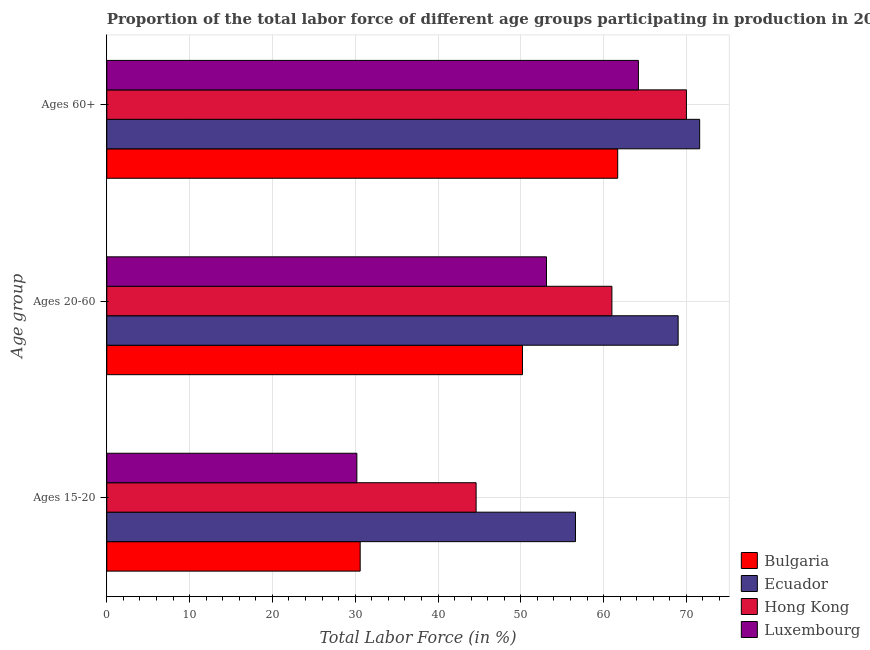How many different coloured bars are there?
Ensure brevity in your answer.  4. Are the number of bars per tick equal to the number of legend labels?
Give a very brief answer. Yes. Are the number of bars on each tick of the Y-axis equal?
Keep it short and to the point. Yes. How many bars are there on the 2nd tick from the top?
Make the answer very short. 4. What is the label of the 2nd group of bars from the top?
Give a very brief answer. Ages 20-60. What is the percentage of labor force within the age group 15-20 in Bulgaria?
Provide a short and direct response. 30.6. Across all countries, what is the maximum percentage of labor force within the age group 20-60?
Offer a terse response. 69. Across all countries, what is the minimum percentage of labor force within the age group 15-20?
Ensure brevity in your answer.  30.2. In which country was the percentage of labor force within the age group 20-60 maximum?
Give a very brief answer. Ecuador. In which country was the percentage of labor force within the age group 20-60 minimum?
Offer a very short reply. Bulgaria. What is the total percentage of labor force within the age group 20-60 in the graph?
Give a very brief answer. 233.3. What is the difference between the percentage of labor force above age 60 in Bulgaria and that in Luxembourg?
Make the answer very short. -2.5. What is the difference between the percentage of labor force within the age group 15-20 in Bulgaria and the percentage of labor force within the age group 20-60 in Luxembourg?
Keep it short and to the point. -22.5. What is the average percentage of labor force above age 60 per country?
Offer a very short reply. 66.87. What is the difference between the percentage of labor force within the age group 20-60 and percentage of labor force within the age group 15-20 in Hong Kong?
Your answer should be compact. 16.4. What is the ratio of the percentage of labor force within the age group 20-60 in Hong Kong to that in Bulgaria?
Give a very brief answer. 1.22. Is the percentage of labor force within the age group 15-20 in Hong Kong less than that in Bulgaria?
Your response must be concise. No. Is the difference between the percentage of labor force above age 60 in Ecuador and Luxembourg greater than the difference between the percentage of labor force within the age group 15-20 in Ecuador and Luxembourg?
Ensure brevity in your answer.  No. What is the difference between the highest and the lowest percentage of labor force within the age group 20-60?
Ensure brevity in your answer.  18.8. In how many countries, is the percentage of labor force above age 60 greater than the average percentage of labor force above age 60 taken over all countries?
Your answer should be compact. 2. Is the sum of the percentage of labor force within the age group 15-20 in Ecuador and Bulgaria greater than the maximum percentage of labor force above age 60 across all countries?
Provide a succinct answer. Yes. What does the 3rd bar from the top in Ages 20-60 represents?
Your answer should be very brief. Ecuador. What does the 4th bar from the bottom in Ages 15-20 represents?
Your response must be concise. Luxembourg. Is it the case that in every country, the sum of the percentage of labor force within the age group 15-20 and percentage of labor force within the age group 20-60 is greater than the percentage of labor force above age 60?
Make the answer very short. Yes. Are all the bars in the graph horizontal?
Provide a short and direct response. Yes. Does the graph contain any zero values?
Your response must be concise. No. Does the graph contain grids?
Keep it short and to the point. Yes. How are the legend labels stacked?
Offer a very short reply. Vertical. What is the title of the graph?
Your response must be concise. Proportion of the total labor force of different age groups participating in production in 2003. Does "Middle East & North Africa (all income levels)" appear as one of the legend labels in the graph?
Your answer should be compact. No. What is the label or title of the Y-axis?
Provide a succinct answer. Age group. What is the Total Labor Force (in %) in Bulgaria in Ages 15-20?
Give a very brief answer. 30.6. What is the Total Labor Force (in %) in Ecuador in Ages 15-20?
Keep it short and to the point. 56.6. What is the Total Labor Force (in %) of Hong Kong in Ages 15-20?
Your response must be concise. 44.6. What is the Total Labor Force (in %) of Luxembourg in Ages 15-20?
Your answer should be compact. 30.2. What is the Total Labor Force (in %) in Bulgaria in Ages 20-60?
Provide a succinct answer. 50.2. What is the Total Labor Force (in %) of Luxembourg in Ages 20-60?
Your answer should be compact. 53.1. What is the Total Labor Force (in %) of Bulgaria in Ages 60+?
Give a very brief answer. 61.7. What is the Total Labor Force (in %) of Ecuador in Ages 60+?
Your answer should be compact. 71.6. What is the Total Labor Force (in %) of Luxembourg in Ages 60+?
Provide a short and direct response. 64.2. Across all Age group, what is the maximum Total Labor Force (in %) in Bulgaria?
Keep it short and to the point. 61.7. Across all Age group, what is the maximum Total Labor Force (in %) in Ecuador?
Offer a terse response. 71.6. Across all Age group, what is the maximum Total Labor Force (in %) of Hong Kong?
Provide a short and direct response. 70. Across all Age group, what is the maximum Total Labor Force (in %) of Luxembourg?
Make the answer very short. 64.2. Across all Age group, what is the minimum Total Labor Force (in %) in Bulgaria?
Give a very brief answer. 30.6. Across all Age group, what is the minimum Total Labor Force (in %) of Ecuador?
Ensure brevity in your answer.  56.6. Across all Age group, what is the minimum Total Labor Force (in %) in Hong Kong?
Your answer should be very brief. 44.6. Across all Age group, what is the minimum Total Labor Force (in %) of Luxembourg?
Keep it short and to the point. 30.2. What is the total Total Labor Force (in %) in Bulgaria in the graph?
Your response must be concise. 142.5. What is the total Total Labor Force (in %) of Ecuador in the graph?
Give a very brief answer. 197.2. What is the total Total Labor Force (in %) in Hong Kong in the graph?
Your answer should be compact. 175.6. What is the total Total Labor Force (in %) of Luxembourg in the graph?
Provide a short and direct response. 147.5. What is the difference between the Total Labor Force (in %) in Bulgaria in Ages 15-20 and that in Ages 20-60?
Keep it short and to the point. -19.6. What is the difference between the Total Labor Force (in %) of Ecuador in Ages 15-20 and that in Ages 20-60?
Offer a terse response. -12.4. What is the difference between the Total Labor Force (in %) of Hong Kong in Ages 15-20 and that in Ages 20-60?
Provide a succinct answer. -16.4. What is the difference between the Total Labor Force (in %) of Luxembourg in Ages 15-20 and that in Ages 20-60?
Provide a succinct answer. -22.9. What is the difference between the Total Labor Force (in %) in Bulgaria in Ages 15-20 and that in Ages 60+?
Offer a very short reply. -31.1. What is the difference between the Total Labor Force (in %) in Ecuador in Ages 15-20 and that in Ages 60+?
Keep it short and to the point. -15. What is the difference between the Total Labor Force (in %) of Hong Kong in Ages 15-20 and that in Ages 60+?
Offer a terse response. -25.4. What is the difference between the Total Labor Force (in %) in Luxembourg in Ages 15-20 and that in Ages 60+?
Offer a terse response. -34. What is the difference between the Total Labor Force (in %) of Ecuador in Ages 20-60 and that in Ages 60+?
Keep it short and to the point. -2.6. What is the difference between the Total Labor Force (in %) in Hong Kong in Ages 20-60 and that in Ages 60+?
Keep it short and to the point. -9. What is the difference between the Total Labor Force (in %) in Bulgaria in Ages 15-20 and the Total Labor Force (in %) in Ecuador in Ages 20-60?
Your response must be concise. -38.4. What is the difference between the Total Labor Force (in %) in Bulgaria in Ages 15-20 and the Total Labor Force (in %) in Hong Kong in Ages 20-60?
Your response must be concise. -30.4. What is the difference between the Total Labor Force (in %) of Bulgaria in Ages 15-20 and the Total Labor Force (in %) of Luxembourg in Ages 20-60?
Offer a terse response. -22.5. What is the difference between the Total Labor Force (in %) in Ecuador in Ages 15-20 and the Total Labor Force (in %) in Hong Kong in Ages 20-60?
Keep it short and to the point. -4.4. What is the difference between the Total Labor Force (in %) of Ecuador in Ages 15-20 and the Total Labor Force (in %) of Luxembourg in Ages 20-60?
Provide a short and direct response. 3.5. What is the difference between the Total Labor Force (in %) of Bulgaria in Ages 15-20 and the Total Labor Force (in %) of Ecuador in Ages 60+?
Provide a short and direct response. -41. What is the difference between the Total Labor Force (in %) of Bulgaria in Ages 15-20 and the Total Labor Force (in %) of Hong Kong in Ages 60+?
Give a very brief answer. -39.4. What is the difference between the Total Labor Force (in %) of Bulgaria in Ages 15-20 and the Total Labor Force (in %) of Luxembourg in Ages 60+?
Your response must be concise. -33.6. What is the difference between the Total Labor Force (in %) in Ecuador in Ages 15-20 and the Total Labor Force (in %) in Luxembourg in Ages 60+?
Ensure brevity in your answer.  -7.6. What is the difference between the Total Labor Force (in %) in Hong Kong in Ages 15-20 and the Total Labor Force (in %) in Luxembourg in Ages 60+?
Provide a succinct answer. -19.6. What is the difference between the Total Labor Force (in %) of Bulgaria in Ages 20-60 and the Total Labor Force (in %) of Ecuador in Ages 60+?
Provide a short and direct response. -21.4. What is the difference between the Total Labor Force (in %) in Bulgaria in Ages 20-60 and the Total Labor Force (in %) in Hong Kong in Ages 60+?
Your answer should be compact. -19.8. What is the difference between the Total Labor Force (in %) of Bulgaria in Ages 20-60 and the Total Labor Force (in %) of Luxembourg in Ages 60+?
Provide a succinct answer. -14. What is the difference between the Total Labor Force (in %) of Ecuador in Ages 20-60 and the Total Labor Force (in %) of Luxembourg in Ages 60+?
Your response must be concise. 4.8. What is the difference between the Total Labor Force (in %) of Hong Kong in Ages 20-60 and the Total Labor Force (in %) of Luxembourg in Ages 60+?
Give a very brief answer. -3.2. What is the average Total Labor Force (in %) of Bulgaria per Age group?
Your response must be concise. 47.5. What is the average Total Labor Force (in %) in Ecuador per Age group?
Make the answer very short. 65.73. What is the average Total Labor Force (in %) of Hong Kong per Age group?
Give a very brief answer. 58.53. What is the average Total Labor Force (in %) in Luxembourg per Age group?
Make the answer very short. 49.17. What is the difference between the Total Labor Force (in %) of Bulgaria and Total Labor Force (in %) of Ecuador in Ages 15-20?
Your answer should be very brief. -26. What is the difference between the Total Labor Force (in %) of Ecuador and Total Labor Force (in %) of Hong Kong in Ages 15-20?
Offer a terse response. 12. What is the difference between the Total Labor Force (in %) of Ecuador and Total Labor Force (in %) of Luxembourg in Ages 15-20?
Provide a succinct answer. 26.4. What is the difference between the Total Labor Force (in %) in Bulgaria and Total Labor Force (in %) in Ecuador in Ages 20-60?
Keep it short and to the point. -18.8. What is the difference between the Total Labor Force (in %) in Bulgaria and Total Labor Force (in %) in Hong Kong in Ages 20-60?
Offer a very short reply. -10.8. What is the difference between the Total Labor Force (in %) of Bulgaria and Total Labor Force (in %) of Luxembourg in Ages 20-60?
Your response must be concise. -2.9. What is the difference between the Total Labor Force (in %) of Ecuador and Total Labor Force (in %) of Luxembourg in Ages 20-60?
Your response must be concise. 15.9. What is the difference between the Total Labor Force (in %) of Hong Kong and Total Labor Force (in %) of Luxembourg in Ages 20-60?
Ensure brevity in your answer.  7.9. What is the difference between the Total Labor Force (in %) in Bulgaria and Total Labor Force (in %) in Ecuador in Ages 60+?
Your answer should be very brief. -9.9. What is the difference between the Total Labor Force (in %) of Bulgaria and Total Labor Force (in %) of Luxembourg in Ages 60+?
Your response must be concise. -2.5. What is the difference between the Total Labor Force (in %) of Hong Kong and Total Labor Force (in %) of Luxembourg in Ages 60+?
Offer a very short reply. 5.8. What is the ratio of the Total Labor Force (in %) in Bulgaria in Ages 15-20 to that in Ages 20-60?
Provide a short and direct response. 0.61. What is the ratio of the Total Labor Force (in %) of Ecuador in Ages 15-20 to that in Ages 20-60?
Ensure brevity in your answer.  0.82. What is the ratio of the Total Labor Force (in %) in Hong Kong in Ages 15-20 to that in Ages 20-60?
Ensure brevity in your answer.  0.73. What is the ratio of the Total Labor Force (in %) of Luxembourg in Ages 15-20 to that in Ages 20-60?
Make the answer very short. 0.57. What is the ratio of the Total Labor Force (in %) of Bulgaria in Ages 15-20 to that in Ages 60+?
Make the answer very short. 0.5. What is the ratio of the Total Labor Force (in %) in Ecuador in Ages 15-20 to that in Ages 60+?
Provide a short and direct response. 0.79. What is the ratio of the Total Labor Force (in %) in Hong Kong in Ages 15-20 to that in Ages 60+?
Provide a succinct answer. 0.64. What is the ratio of the Total Labor Force (in %) of Luxembourg in Ages 15-20 to that in Ages 60+?
Your response must be concise. 0.47. What is the ratio of the Total Labor Force (in %) in Bulgaria in Ages 20-60 to that in Ages 60+?
Give a very brief answer. 0.81. What is the ratio of the Total Labor Force (in %) in Ecuador in Ages 20-60 to that in Ages 60+?
Your response must be concise. 0.96. What is the ratio of the Total Labor Force (in %) in Hong Kong in Ages 20-60 to that in Ages 60+?
Your response must be concise. 0.87. What is the ratio of the Total Labor Force (in %) of Luxembourg in Ages 20-60 to that in Ages 60+?
Your answer should be compact. 0.83. What is the difference between the highest and the second highest Total Labor Force (in %) in Bulgaria?
Your answer should be compact. 11.5. What is the difference between the highest and the second highest Total Labor Force (in %) of Hong Kong?
Offer a terse response. 9. What is the difference between the highest and the second highest Total Labor Force (in %) of Luxembourg?
Give a very brief answer. 11.1. What is the difference between the highest and the lowest Total Labor Force (in %) in Bulgaria?
Make the answer very short. 31.1. What is the difference between the highest and the lowest Total Labor Force (in %) in Hong Kong?
Give a very brief answer. 25.4. What is the difference between the highest and the lowest Total Labor Force (in %) in Luxembourg?
Keep it short and to the point. 34. 